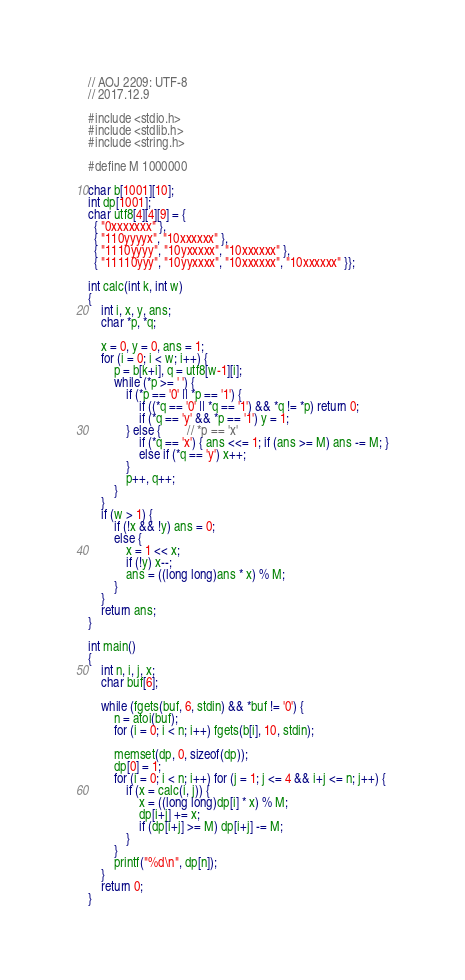<code> <loc_0><loc_0><loc_500><loc_500><_C_>// AOJ 2209: UTF-8
// 2017.12.9

#include <stdio.h>
#include <stdlib.h>
#include <string.h>

#define M 1000000

char b[1001][10];
int dp[1001];
char utf8[4][4][9] = {
  { "0xxxxxxx" },
  { "110yyyyx", "10xxxxxx" },
  { "1110yyyy", "10yxxxxx", "10xxxxxx" },
  { "11110yyy", "10yyxxxx", "10xxxxxx", "10xxxxxx" }};

int calc(int k, int w)
{
	int i, x, y, ans;
	char *p, *q;

	x = 0, y = 0, ans = 1;
	for (i = 0; i < w; i++) {
		p = b[k+i], q = utf8[w-1][i];
		while (*p >= ' ') {
			if (*p == '0' || *p == '1') {
				if ((*q == '0' || *q == '1') && *q != *p) return 0;
				if (*q == 'y' && *p == '1') y = 1;
			} else {		// *p == 'x'
				if (*q == 'x') { ans <<= 1; if (ans >= M) ans -= M; }
				else if (*q == 'y') x++;
			}
			p++, q++;
		}
	}
	if (w > 1) {
		if (!x && !y) ans = 0;
		else {
			x = 1 << x;
			if (!y) x--;
			ans = ((long long)ans * x) % M;
		}
	}
	return ans;
}

int main()
{
	int n, i, j, x;
	char buf[6];

	while (fgets(buf, 6, stdin) && *buf != '0') {
		n = atoi(buf);
		for (i = 0; i < n; i++) fgets(b[i], 10, stdin);

		memset(dp, 0, sizeof(dp));
		dp[0] = 1;
		for (i = 0; i < n; i++) for (j = 1; j <= 4 && i+j <= n; j++) {
			if (x = calc(i, j)) {
				x = ((long long)dp[i] * x) % M;
				dp[i+j] += x;
				if (dp[i+j] >= M) dp[i+j] -= M;
			}
		}
		printf("%d\n", dp[n]);
	}
	return 0;
}</code> 